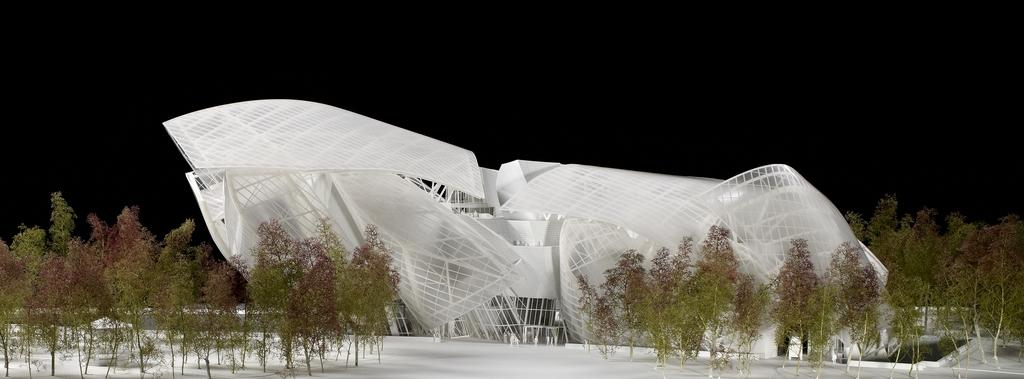What is the main subject in the middle of the image? There is a museum in the middle of the image. What can be seen on either side of the museum? There are trees on either side of the museum. How many girls are present in the image? There is no girl present in the image; it features a museum with trees on either side. What is the rate of the museum's expansion in the image? The image does not provide information about the museum's expansion rate. 